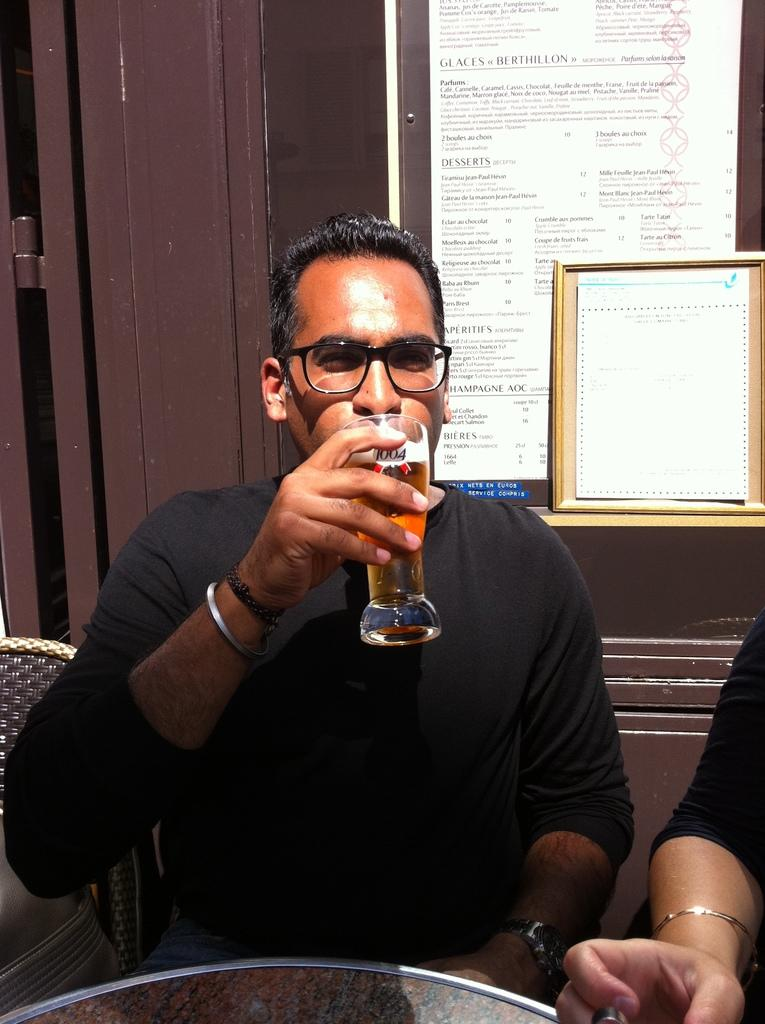What is the main subject of the image? There is a man in the image. What is the man doing in the image? The man is sitting. What is the man holding in his hand? The man is holding a wine glass in his hand. What can be seen in the background of the image? There are papers and a photo frame in the background of the image. Where is the photo frame located in the image? The photo frame is kept on a door. How many sisters does the man have in the image? There is no information about the man's sisters in the image. What type of expansion is visible on the door where the photo frame is kept? There is no mention of any expansion on the door in the image. 